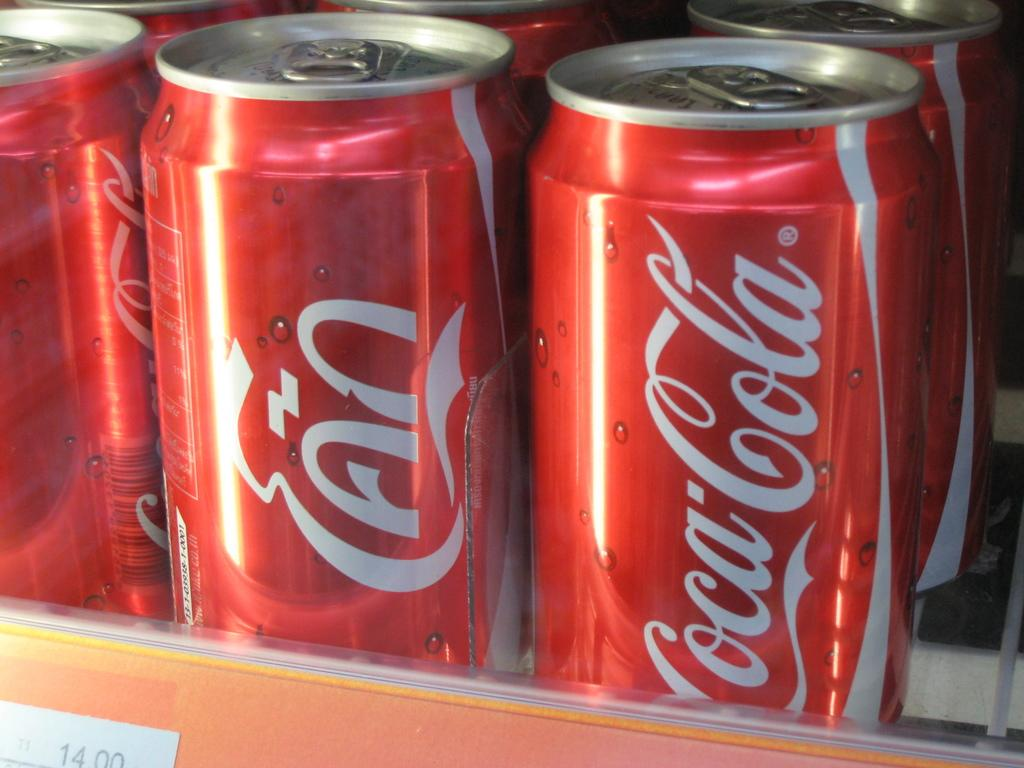<image>
Write a terse but informative summary of the picture. A display of cans of Coca Cola, one of which has foreign writing showing. 